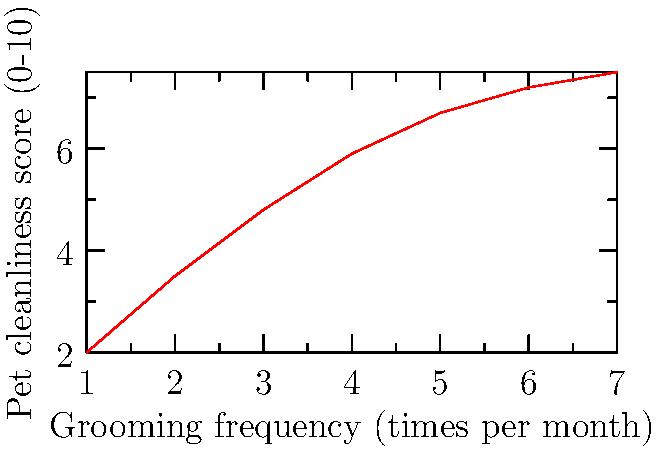Based on the line graph showing the relationship between grooming frequency and pet cleanliness, what is the approximate increase in cleanliness score when grooming frequency increases from 2 to 5 times per month? To find the increase in cleanliness score, we need to:

1. Identify the cleanliness score at 2 grooming sessions per month:
   At x = 2, y ≈ 3.5

2. Identify the cleanliness score at 5 grooming sessions per month:
   At x = 5, y ≈ 6.7

3. Calculate the difference:
   $\Delta y = y_5 - y_2 = 6.7 - 3.5 = 3.2$

The cleanliness score increases by approximately 3.2 points when grooming frequency increases from 2 to 5 times per month.
Answer: 3.2 